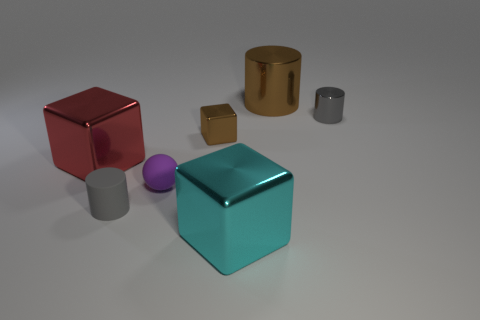Subtract all tiny gray matte cylinders. How many cylinders are left? 2 Add 2 large cylinders. How many objects exist? 9 Subtract all purple cubes. How many gray cylinders are left? 2 Subtract all gray cylinders. How many cylinders are left? 1 Subtract all cylinders. How many objects are left? 4 Subtract 1 balls. How many balls are left? 0 Subtract all purple cylinders. Subtract all green blocks. How many cylinders are left? 3 Subtract all large green rubber objects. Subtract all small blocks. How many objects are left? 6 Add 2 big metal objects. How many big metal objects are left? 5 Add 3 metal cylinders. How many metal cylinders exist? 5 